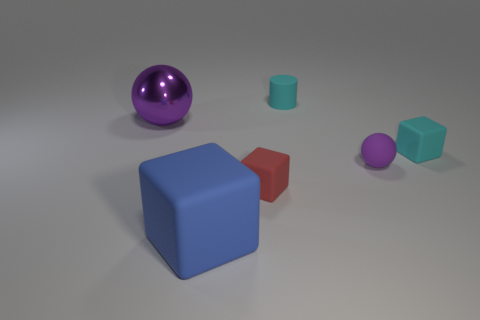Is there a tiny rubber cube that has the same color as the small cylinder?
Give a very brief answer. Yes. Do the metal sphere and the sphere to the right of the red matte cube have the same color?
Offer a terse response. Yes. What is the tiny sphere made of?
Your answer should be compact. Rubber. What number of cylinders are either rubber objects or blue rubber things?
Provide a short and direct response. 1. Is the material of the blue block the same as the big purple object?
Your answer should be compact. No. What size is the cyan matte thing that is the same shape as the blue matte thing?
Provide a short and direct response. Small. What material is the object that is in front of the big ball and behind the tiny sphere?
Provide a succinct answer. Rubber. Is the number of small things on the left side of the large blue thing the same as the number of big matte things?
Your answer should be very brief. No. What number of things are either purple balls behind the purple matte ball or metal things?
Your answer should be compact. 1. Do the matte cube to the right of the red matte object and the cylinder have the same color?
Make the answer very short. Yes. 